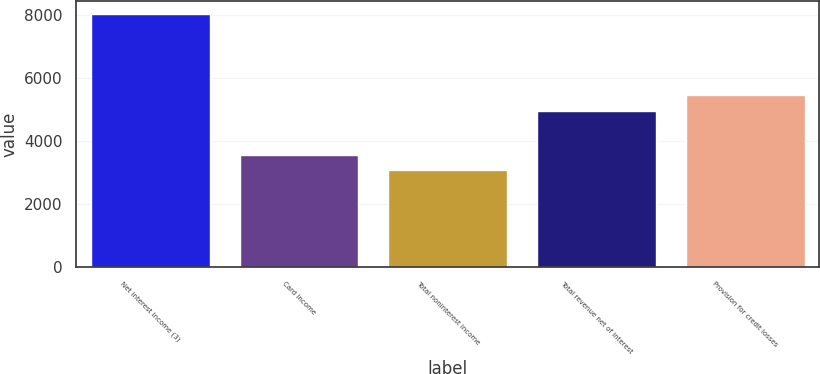Convert chart to OTSL. <chart><loc_0><loc_0><loc_500><loc_500><bar_chart><fcel>Net interest income (3)<fcel>Card income<fcel>Total noninterest income<fcel>Total revenue net of interest<fcel>Provision for credit losses<nl><fcel>8027<fcel>3563.9<fcel>3068<fcel>4959<fcel>5454.9<nl></chart> 